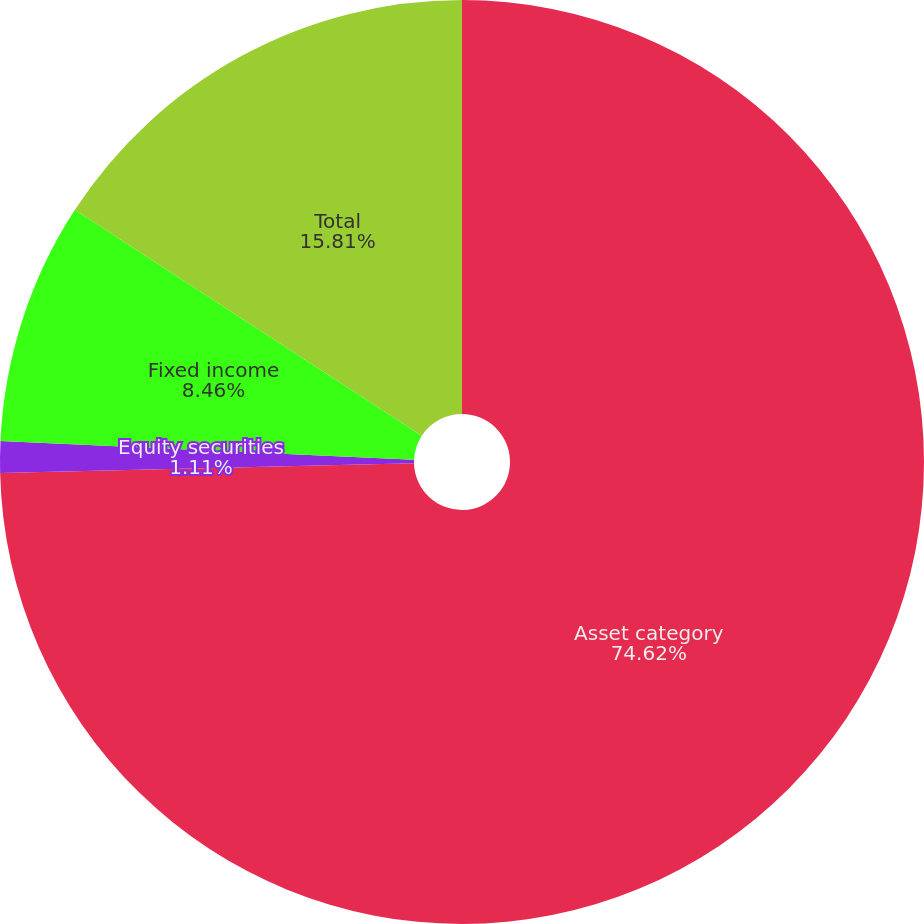<chart> <loc_0><loc_0><loc_500><loc_500><pie_chart><fcel>Asset category<fcel>Equity securities<fcel>Fixed income<fcel>Total<nl><fcel>74.61%<fcel>1.11%<fcel>8.46%<fcel>15.81%<nl></chart> 